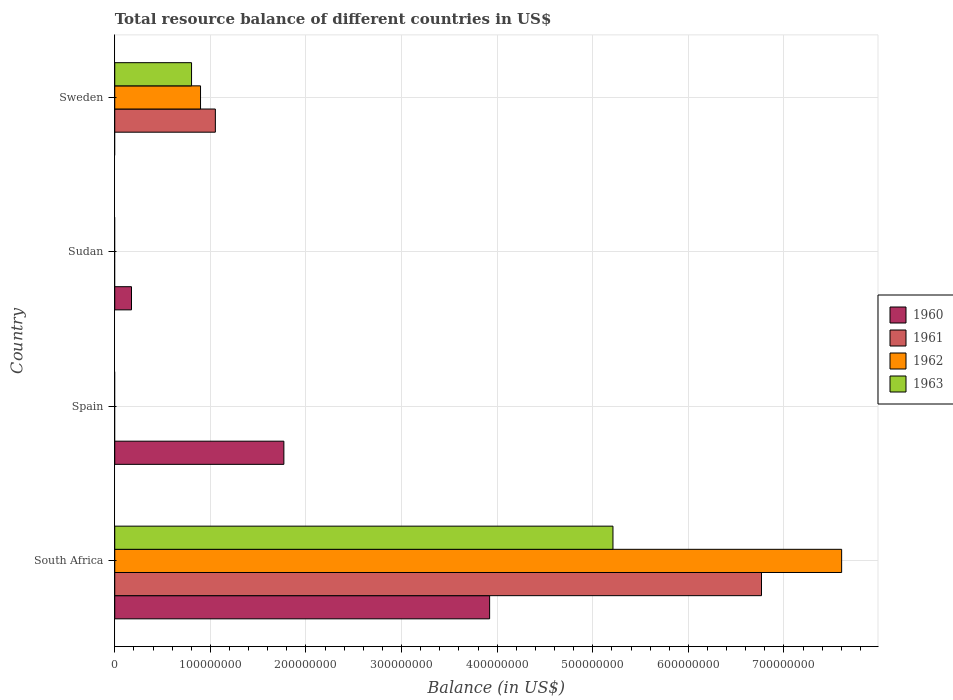Are the number of bars on each tick of the Y-axis equal?
Provide a succinct answer. No. How many bars are there on the 1st tick from the bottom?
Offer a terse response. 4. What is the label of the 4th group of bars from the top?
Provide a succinct answer. South Africa. In how many cases, is the number of bars for a given country not equal to the number of legend labels?
Make the answer very short. 3. Across all countries, what is the maximum total resource balance in 1962?
Provide a short and direct response. 7.60e+08. Across all countries, what is the minimum total resource balance in 1963?
Your answer should be compact. 0. In which country was the total resource balance in 1960 maximum?
Keep it short and to the point. South Africa. What is the total total resource balance in 1963 in the graph?
Provide a succinct answer. 6.01e+08. What is the difference between the total resource balance in 1960 in South Africa and that in Spain?
Give a very brief answer. 2.15e+08. What is the difference between the total resource balance in 1963 in South Africa and the total resource balance in 1960 in Spain?
Offer a very short reply. 3.44e+08. What is the average total resource balance in 1962 per country?
Give a very brief answer. 2.13e+08. What is the difference between the total resource balance in 1960 and total resource balance in 1961 in South Africa?
Keep it short and to the point. -2.84e+08. Is the total resource balance in 1963 in South Africa less than that in Sweden?
Keep it short and to the point. No. What is the difference between the highest and the second highest total resource balance in 1960?
Ensure brevity in your answer.  2.15e+08. What is the difference between the highest and the lowest total resource balance in 1960?
Offer a terse response. 3.92e+08. In how many countries, is the total resource balance in 1962 greater than the average total resource balance in 1962 taken over all countries?
Offer a very short reply. 1. Is it the case that in every country, the sum of the total resource balance in 1960 and total resource balance in 1961 is greater than the sum of total resource balance in 1962 and total resource balance in 1963?
Give a very brief answer. Yes. Is it the case that in every country, the sum of the total resource balance in 1962 and total resource balance in 1963 is greater than the total resource balance in 1961?
Make the answer very short. No. How many bars are there?
Give a very brief answer. 9. Are all the bars in the graph horizontal?
Your response must be concise. Yes. How many countries are there in the graph?
Keep it short and to the point. 4. Does the graph contain any zero values?
Provide a short and direct response. Yes. Where does the legend appear in the graph?
Provide a succinct answer. Center right. What is the title of the graph?
Keep it short and to the point. Total resource balance of different countries in US$. What is the label or title of the X-axis?
Provide a short and direct response. Balance (in US$). What is the Balance (in US$) of 1960 in South Africa?
Your answer should be very brief. 3.92e+08. What is the Balance (in US$) in 1961 in South Africa?
Offer a terse response. 6.77e+08. What is the Balance (in US$) of 1962 in South Africa?
Give a very brief answer. 7.60e+08. What is the Balance (in US$) in 1963 in South Africa?
Offer a terse response. 5.21e+08. What is the Balance (in US$) of 1960 in Spain?
Offer a very short reply. 1.77e+08. What is the Balance (in US$) of 1961 in Spain?
Ensure brevity in your answer.  0. What is the Balance (in US$) of 1962 in Spain?
Provide a short and direct response. 0. What is the Balance (in US$) of 1963 in Spain?
Provide a succinct answer. 0. What is the Balance (in US$) of 1960 in Sudan?
Your answer should be very brief. 1.75e+07. What is the Balance (in US$) of 1961 in Sudan?
Your answer should be very brief. 0. What is the Balance (in US$) in 1962 in Sudan?
Your answer should be compact. 0. What is the Balance (in US$) in 1963 in Sudan?
Make the answer very short. 0. What is the Balance (in US$) of 1961 in Sweden?
Provide a short and direct response. 1.05e+08. What is the Balance (in US$) in 1962 in Sweden?
Ensure brevity in your answer.  8.97e+07. What is the Balance (in US$) in 1963 in Sweden?
Give a very brief answer. 8.03e+07. Across all countries, what is the maximum Balance (in US$) of 1960?
Your answer should be very brief. 3.92e+08. Across all countries, what is the maximum Balance (in US$) of 1961?
Offer a very short reply. 6.77e+08. Across all countries, what is the maximum Balance (in US$) in 1962?
Make the answer very short. 7.60e+08. Across all countries, what is the maximum Balance (in US$) in 1963?
Offer a very short reply. 5.21e+08. Across all countries, what is the minimum Balance (in US$) of 1960?
Your answer should be very brief. 0. What is the total Balance (in US$) in 1960 in the graph?
Provide a succinct answer. 5.87e+08. What is the total Balance (in US$) of 1961 in the graph?
Provide a succinct answer. 7.82e+08. What is the total Balance (in US$) of 1962 in the graph?
Offer a very short reply. 8.50e+08. What is the total Balance (in US$) of 1963 in the graph?
Your response must be concise. 6.01e+08. What is the difference between the Balance (in US$) in 1960 in South Africa and that in Spain?
Ensure brevity in your answer.  2.15e+08. What is the difference between the Balance (in US$) in 1960 in South Africa and that in Sudan?
Give a very brief answer. 3.75e+08. What is the difference between the Balance (in US$) of 1961 in South Africa and that in Sweden?
Offer a very short reply. 5.71e+08. What is the difference between the Balance (in US$) of 1962 in South Africa and that in Sweden?
Offer a terse response. 6.71e+08. What is the difference between the Balance (in US$) in 1963 in South Africa and that in Sweden?
Your answer should be very brief. 4.41e+08. What is the difference between the Balance (in US$) of 1960 in Spain and that in Sudan?
Your answer should be very brief. 1.59e+08. What is the difference between the Balance (in US$) of 1960 in South Africa and the Balance (in US$) of 1961 in Sweden?
Ensure brevity in your answer.  2.87e+08. What is the difference between the Balance (in US$) of 1960 in South Africa and the Balance (in US$) of 1962 in Sweden?
Provide a short and direct response. 3.02e+08. What is the difference between the Balance (in US$) in 1960 in South Africa and the Balance (in US$) in 1963 in Sweden?
Provide a succinct answer. 3.12e+08. What is the difference between the Balance (in US$) of 1961 in South Africa and the Balance (in US$) of 1962 in Sweden?
Give a very brief answer. 5.87e+08. What is the difference between the Balance (in US$) in 1961 in South Africa and the Balance (in US$) in 1963 in Sweden?
Offer a very short reply. 5.96e+08. What is the difference between the Balance (in US$) in 1962 in South Africa and the Balance (in US$) in 1963 in Sweden?
Keep it short and to the point. 6.80e+08. What is the difference between the Balance (in US$) of 1960 in Spain and the Balance (in US$) of 1961 in Sweden?
Offer a very short reply. 7.17e+07. What is the difference between the Balance (in US$) in 1960 in Spain and the Balance (in US$) in 1962 in Sweden?
Make the answer very short. 8.72e+07. What is the difference between the Balance (in US$) of 1960 in Spain and the Balance (in US$) of 1963 in Sweden?
Make the answer very short. 9.66e+07. What is the difference between the Balance (in US$) of 1960 in Sudan and the Balance (in US$) of 1961 in Sweden?
Offer a very short reply. -8.77e+07. What is the difference between the Balance (in US$) of 1960 in Sudan and the Balance (in US$) of 1962 in Sweden?
Offer a terse response. -7.22e+07. What is the difference between the Balance (in US$) of 1960 in Sudan and the Balance (in US$) of 1963 in Sweden?
Make the answer very short. -6.28e+07. What is the average Balance (in US$) in 1960 per country?
Offer a very short reply. 1.47e+08. What is the average Balance (in US$) in 1961 per country?
Provide a short and direct response. 1.95e+08. What is the average Balance (in US$) in 1962 per country?
Make the answer very short. 2.13e+08. What is the average Balance (in US$) of 1963 per country?
Offer a very short reply. 1.50e+08. What is the difference between the Balance (in US$) in 1960 and Balance (in US$) in 1961 in South Africa?
Provide a short and direct response. -2.84e+08. What is the difference between the Balance (in US$) of 1960 and Balance (in US$) of 1962 in South Africa?
Give a very brief answer. -3.68e+08. What is the difference between the Balance (in US$) of 1960 and Balance (in US$) of 1963 in South Africa?
Your response must be concise. -1.29e+08. What is the difference between the Balance (in US$) in 1961 and Balance (in US$) in 1962 in South Africa?
Offer a terse response. -8.38e+07. What is the difference between the Balance (in US$) of 1961 and Balance (in US$) of 1963 in South Africa?
Give a very brief answer. 1.55e+08. What is the difference between the Balance (in US$) in 1962 and Balance (in US$) in 1963 in South Africa?
Provide a short and direct response. 2.39e+08. What is the difference between the Balance (in US$) of 1961 and Balance (in US$) of 1962 in Sweden?
Offer a terse response. 1.55e+07. What is the difference between the Balance (in US$) in 1961 and Balance (in US$) in 1963 in Sweden?
Offer a terse response. 2.49e+07. What is the difference between the Balance (in US$) in 1962 and Balance (in US$) in 1963 in Sweden?
Provide a succinct answer. 9.40e+06. What is the ratio of the Balance (in US$) of 1960 in South Africa to that in Spain?
Keep it short and to the point. 2.22. What is the ratio of the Balance (in US$) of 1960 in South Africa to that in Sudan?
Offer a very short reply. 22.38. What is the ratio of the Balance (in US$) of 1961 in South Africa to that in Sweden?
Your answer should be compact. 6.43. What is the ratio of the Balance (in US$) of 1962 in South Africa to that in Sweden?
Your answer should be compact. 8.47. What is the ratio of the Balance (in US$) of 1963 in South Africa to that in Sweden?
Your response must be concise. 6.49. What is the ratio of the Balance (in US$) in 1960 in Spain to that in Sudan?
Offer a very short reply. 10.1. What is the difference between the highest and the second highest Balance (in US$) of 1960?
Offer a very short reply. 2.15e+08. What is the difference between the highest and the lowest Balance (in US$) of 1960?
Keep it short and to the point. 3.92e+08. What is the difference between the highest and the lowest Balance (in US$) in 1961?
Keep it short and to the point. 6.77e+08. What is the difference between the highest and the lowest Balance (in US$) in 1962?
Your response must be concise. 7.60e+08. What is the difference between the highest and the lowest Balance (in US$) in 1963?
Ensure brevity in your answer.  5.21e+08. 